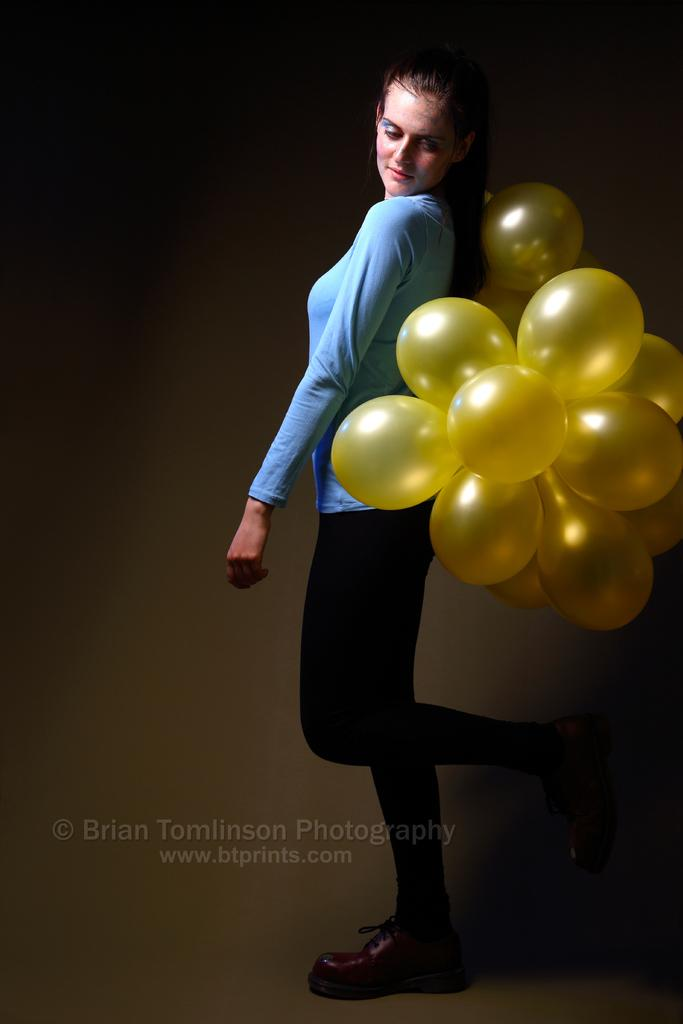What is the main subject of the image? There is a woman standing in the image. What is the woman looking at? The woman is looking towards balloons. Can you describe any additional features of the image? There is a watermark in the image, and the background is brown in color. What type of news is being reported by the group in the image? There is no group present in the image, and no news is being reported. 